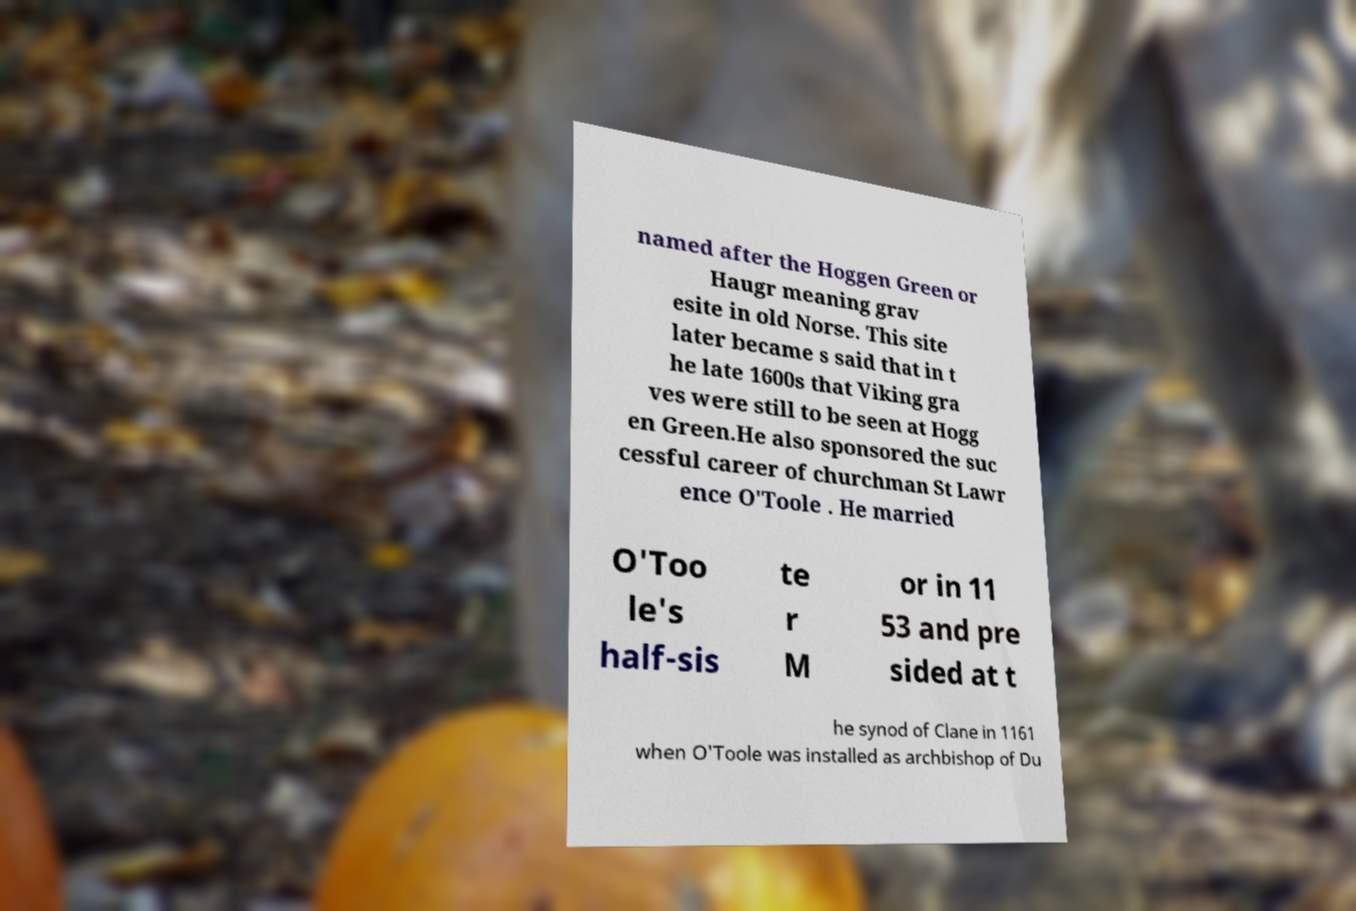Can you read and provide the text displayed in the image?This photo seems to have some interesting text. Can you extract and type it out for me? named after the Hoggen Green or Haugr meaning grav esite in old Norse. This site later became s said that in t he late 1600s that Viking gra ves were still to be seen at Hogg en Green.He also sponsored the suc cessful career of churchman St Lawr ence O'Toole . He married O'Too le's half-sis te r M or in 11 53 and pre sided at t he synod of Clane in 1161 when O'Toole was installed as archbishop of Du 